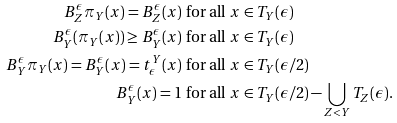<formula> <loc_0><loc_0><loc_500><loc_500>B _ { Z } ^ { \epsilon } \pi _ { Y } ( x ) = B _ { Z } ^ { \epsilon } ( x ) & \text { for all } x \in T _ { Y } ( \epsilon ) \\ B _ { Y } ^ { \epsilon } ( \pi _ { Y } ( x ) ) \geq B _ { Y } ^ { \epsilon } ( x ) & \text { for all } x \in T _ { Y } ( \epsilon ) \\ B _ { Y } ^ { \epsilon } \pi _ { Y } ( x ) = B _ { Y } ^ { \epsilon } ( x ) = t ^ { Y } _ { \epsilon } ( x ) & \text { for all } x \in T _ { Y } ( \epsilon / 2 ) \\ B _ { Y } ^ { \epsilon } ( x ) = 1 & \text { for all } x \in T _ { Y } ( \epsilon / 2 ) - \bigcup _ { Z < Y } T _ { Z } ( \epsilon ) .</formula> 